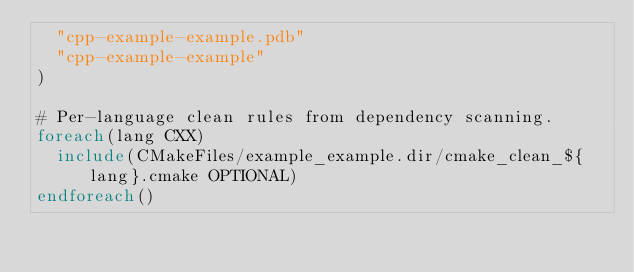Convert code to text. <code><loc_0><loc_0><loc_500><loc_500><_CMake_>  "cpp-example-example.pdb"
  "cpp-example-example"
)

# Per-language clean rules from dependency scanning.
foreach(lang CXX)
  include(CMakeFiles/example_example.dir/cmake_clean_${lang}.cmake OPTIONAL)
endforeach()
</code> 